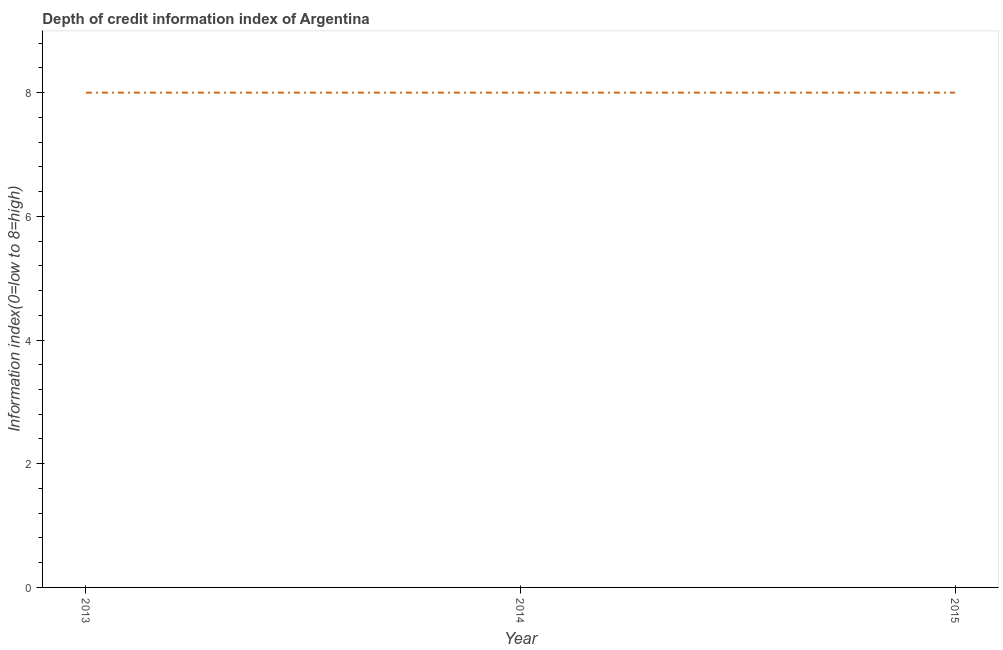What is the depth of credit information index in 2013?
Offer a very short reply. 8. Across all years, what is the maximum depth of credit information index?
Provide a succinct answer. 8. Across all years, what is the minimum depth of credit information index?
Provide a succinct answer. 8. In which year was the depth of credit information index maximum?
Make the answer very short. 2013. In which year was the depth of credit information index minimum?
Provide a short and direct response. 2013. What is the sum of the depth of credit information index?
Provide a short and direct response. 24. What is the median depth of credit information index?
Offer a very short reply. 8. In how many years, is the depth of credit information index greater than 4.8 ?
Provide a short and direct response. 3. Do a majority of the years between 2013 and 2014 (inclusive) have depth of credit information index greater than 3.6 ?
Your answer should be very brief. Yes. Is the depth of credit information index in 2013 less than that in 2014?
Offer a very short reply. No. Is the difference between the depth of credit information index in 2013 and 2014 greater than the difference between any two years?
Your response must be concise. Yes. What is the difference between the highest and the second highest depth of credit information index?
Give a very brief answer. 0. What is the difference between the highest and the lowest depth of credit information index?
Give a very brief answer. 0. Does the depth of credit information index monotonically increase over the years?
Offer a very short reply. No. How many lines are there?
Offer a very short reply. 1. How many years are there in the graph?
Provide a short and direct response. 3. Are the values on the major ticks of Y-axis written in scientific E-notation?
Make the answer very short. No. Does the graph contain any zero values?
Keep it short and to the point. No. What is the title of the graph?
Offer a terse response. Depth of credit information index of Argentina. What is the label or title of the X-axis?
Offer a terse response. Year. What is the label or title of the Y-axis?
Your answer should be compact. Information index(0=low to 8=high). What is the Information index(0=low to 8=high) in 2015?
Ensure brevity in your answer.  8. What is the difference between the Information index(0=low to 8=high) in 2013 and 2015?
Provide a succinct answer. 0. What is the ratio of the Information index(0=low to 8=high) in 2013 to that in 2014?
Ensure brevity in your answer.  1. 